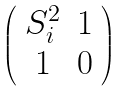Convert formula to latex. <formula><loc_0><loc_0><loc_500><loc_500>\left ( \begin{array} { c c } S _ { i } ^ { 2 } & 1 \\ 1 & 0 \\ \end{array} \right )</formula> 